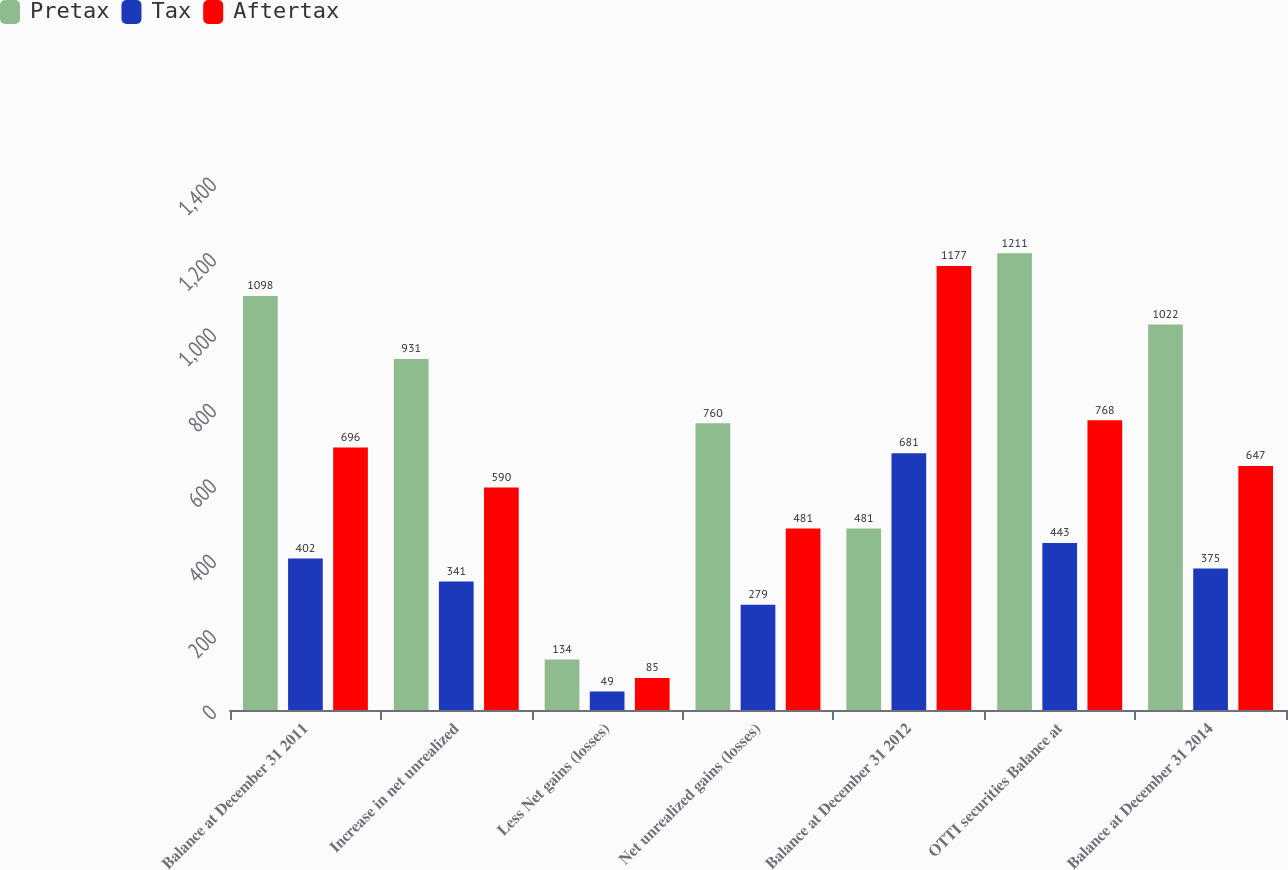<chart> <loc_0><loc_0><loc_500><loc_500><stacked_bar_chart><ecel><fcel>Balance at December 31 2011<fcel>Increase in net unrealized<fcel>Less Net gains (losses)<fcel>Net unrealized gains (losses)<fcel>Balance at December 31 2012<fcel>OTTI securities Balance at<fcel>Balance at December 31 2014<nl><fcel>Pretax<fcel>1098<fcel>931<fcel>134<fcel>760<fcel>481<fcel>1211<fcel>1022<nl><fcel>Tax<fcel>402<fcel>341<fcel>49<fcel>279<fcel>681<fcel>443<fcel>375<nl><fcel>Aftertax<fcel>696<fcel>590<fcel>85<fcel>481<fcel>1177<fcel>768<fcel>647<nl></chart> 